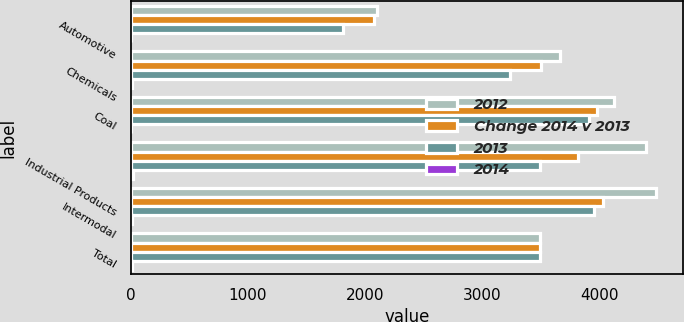Convert chart. <chart><loc_0><loc_0><loc_500><loc_500><stacked_bar_chart><ecel><fcel>Automotive<fcel>Chemicals<fcel>Coal<fcel>Industrial Products<fcel>Intermodal<fcel>Total<nl><fcel>2012<fcel>2103<fcel>3664<fcel>4127<fcel>4400<fcel>4489<fcel>3494<nl><fcel>Change 2014 v 2013<fcel>2077<fcel>3501<fcel>3978<fcel>3822<fcel>4030<fcel>3494<nl><fcel>2013<fcel>1807<fcel>3238<fcel>3912<fcel>3494<fcel>3955<fcel>3494<nl><fcel>2014<fcel>1<fcel>5<fcel>4<fcel>15<fcel>11<fcel>9<nl></chart> 